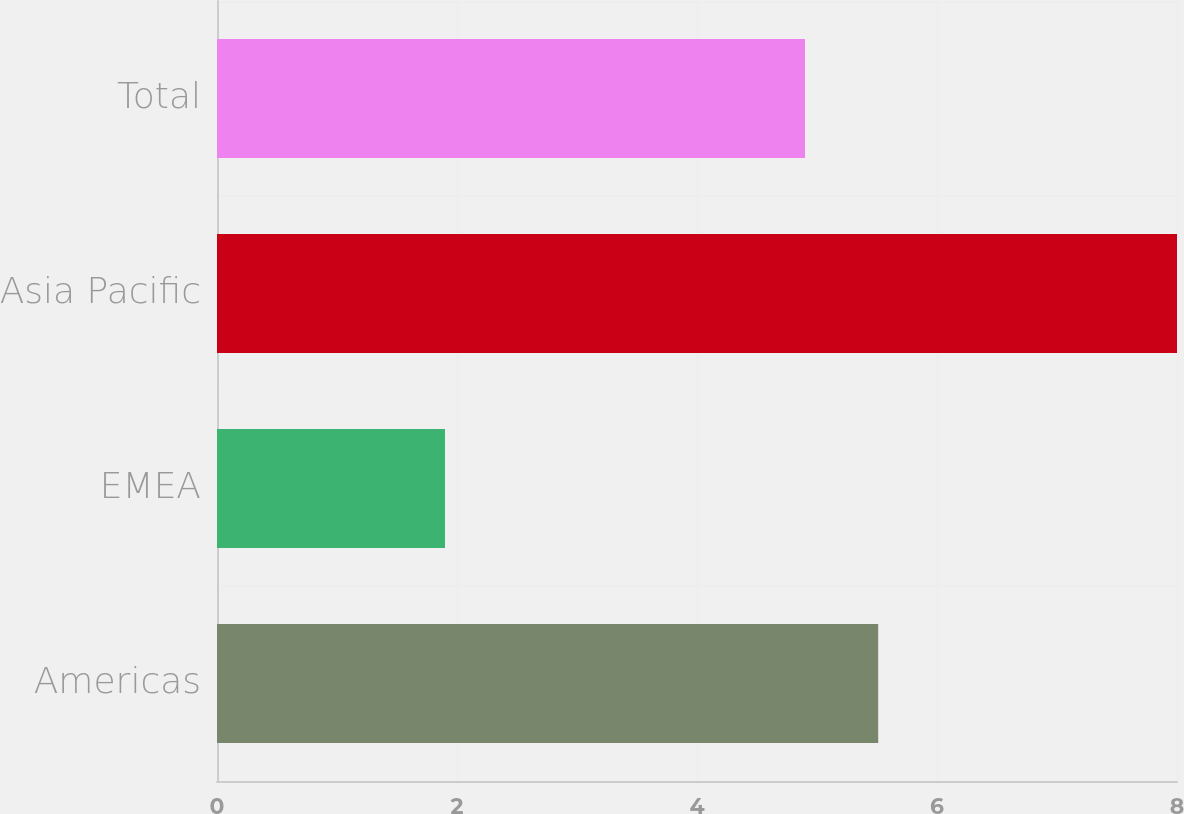<chart> <loc_0><loc_0><loc_500><loc_500><bar_chart><fcel>Americas<fcel>EMEA<fcel>Asia Pacific<fcel>Total<nl><fcel>5.51<fcel>1.9<fcel>8<fcel>4.9<nl></chart> 